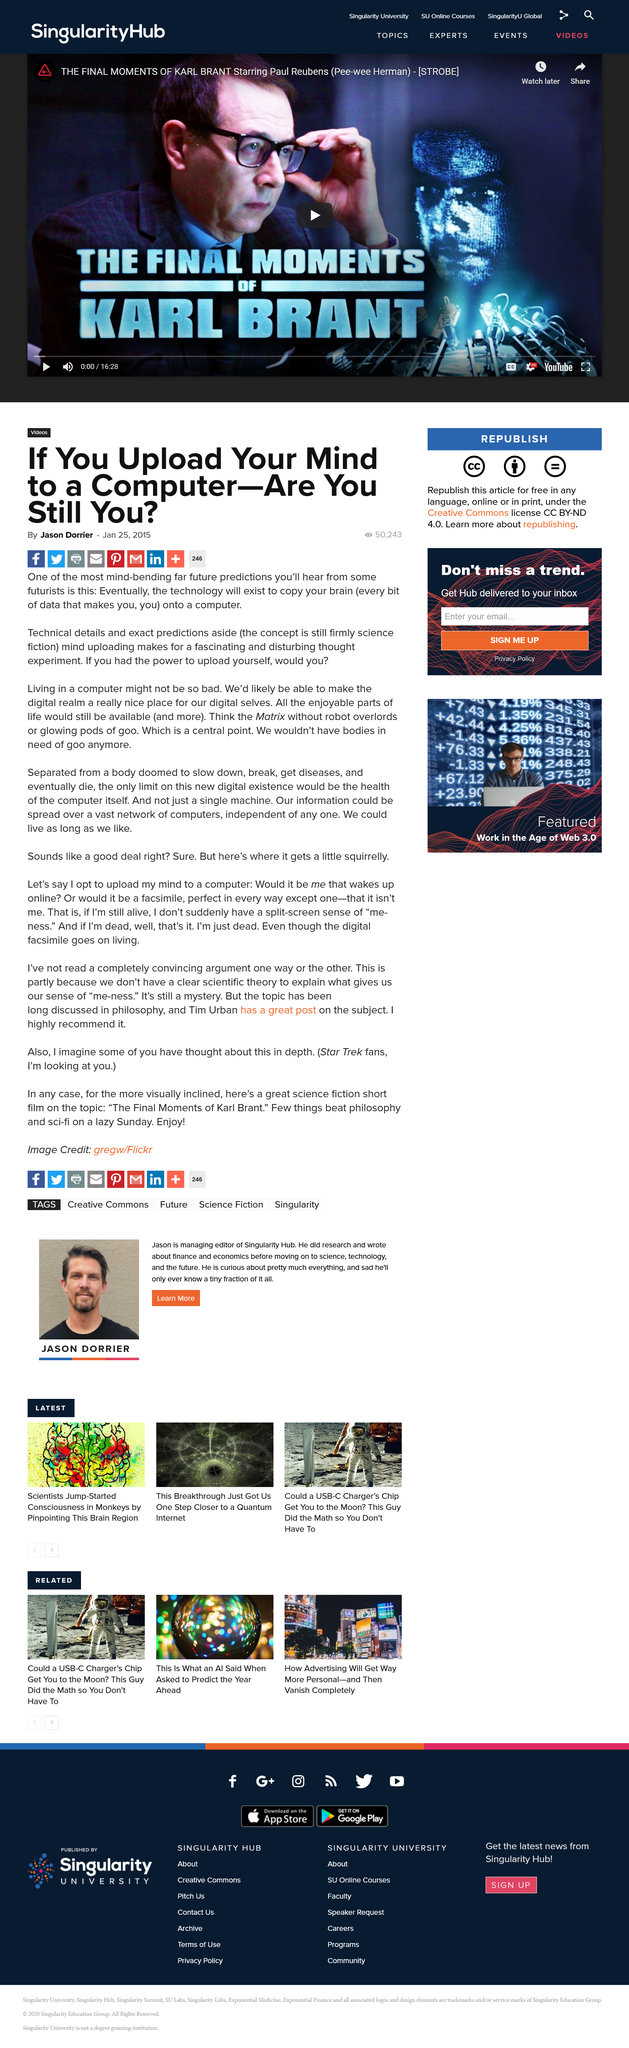Outline some significant characteristics in this image. The article poses the question of whether one would upload themselves if they had the power to do so in the end of the second paragraph of the text. The Matrix, a famous science fiction film, is referenced in this text. It is predicted by futurists that technology will eventually be able to copy a human brain onto a computer. 